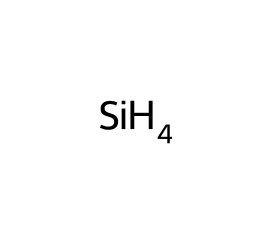What is the molecular formula of this silane? The SMILES representation [SiH4] indicates that the molecule consists of one silicon atom (Si) and four hydrogen atoms (H). Therefore, the molecular formula can be directly deduced as SiH4.
Answer: SiH4 How many hydrogen atoms are present in this silane? In the molecular formula SiH4 derived from the SMILES representation, the "H4" indicates there are four hydrogen atoms attached to the silicon atom.
Answer: 4 What is the primary element in silane? The SMILES representation shows one silicon atom, which is the central atom in the structure, making it the primary element of silane.
Answer: silicon Is silane a saturated or unsaturated compound? Silane has single bonds between silicon and hydrogen atoms as indicated by the structure in the SMILES format. Since all valences of silicon are satisfied with single bonds, silane is classified as a saturated compound.
Answer: saturated What is the hybridization of silicon in silane? In the SMILES representation [SiH4], the silicon atom forms four single bonds to hydrogen atoms, indicating it uses sp3 hybridization, as this type of hybridization corresponds to four equivalent bonds in a tetrahedral geometry.
Answer: sp3 Can silane be found in natural limestone formations? While limestones primarily consist of calcium carbonate, silane and its derivatives can occur in minor quantities as surface coatings or in the context of organic matter, though it is not a primary component of limestone.
Answer: no What type of reaction would silane undergo when exposed to oxygen? Silane can react with oxygen in a combustion reaction, producing silica (SiO2) and water (H2O) as products, which is typical of silanes reacting with oxidizing agents.
Answer: combustion 